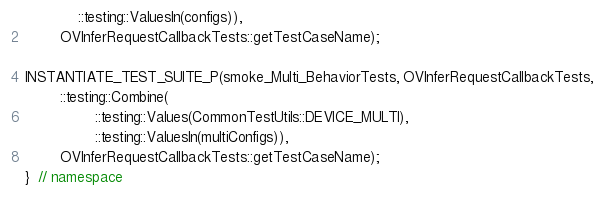<code> <loc_0><loc_0><loc_500><loc_500><_C++_>            ::testing::ValuesIn(configs)),
        OVInferRequestCallbackTests::getTestCaseName);

INSTANTIATE_TEST_SUITE_P(smoke_Multi_BehaviorTests, OVInferRequestCallbackTests,
        ::testing::Combine(
                ::testing::Values(CommonTestUtils::DEVICE_MULTI),
                ::testing::ValuesIn(multiConfigs)),
        OVInferRequestCallbackTests::getTestCaseName);
}  // namespace
</code> 